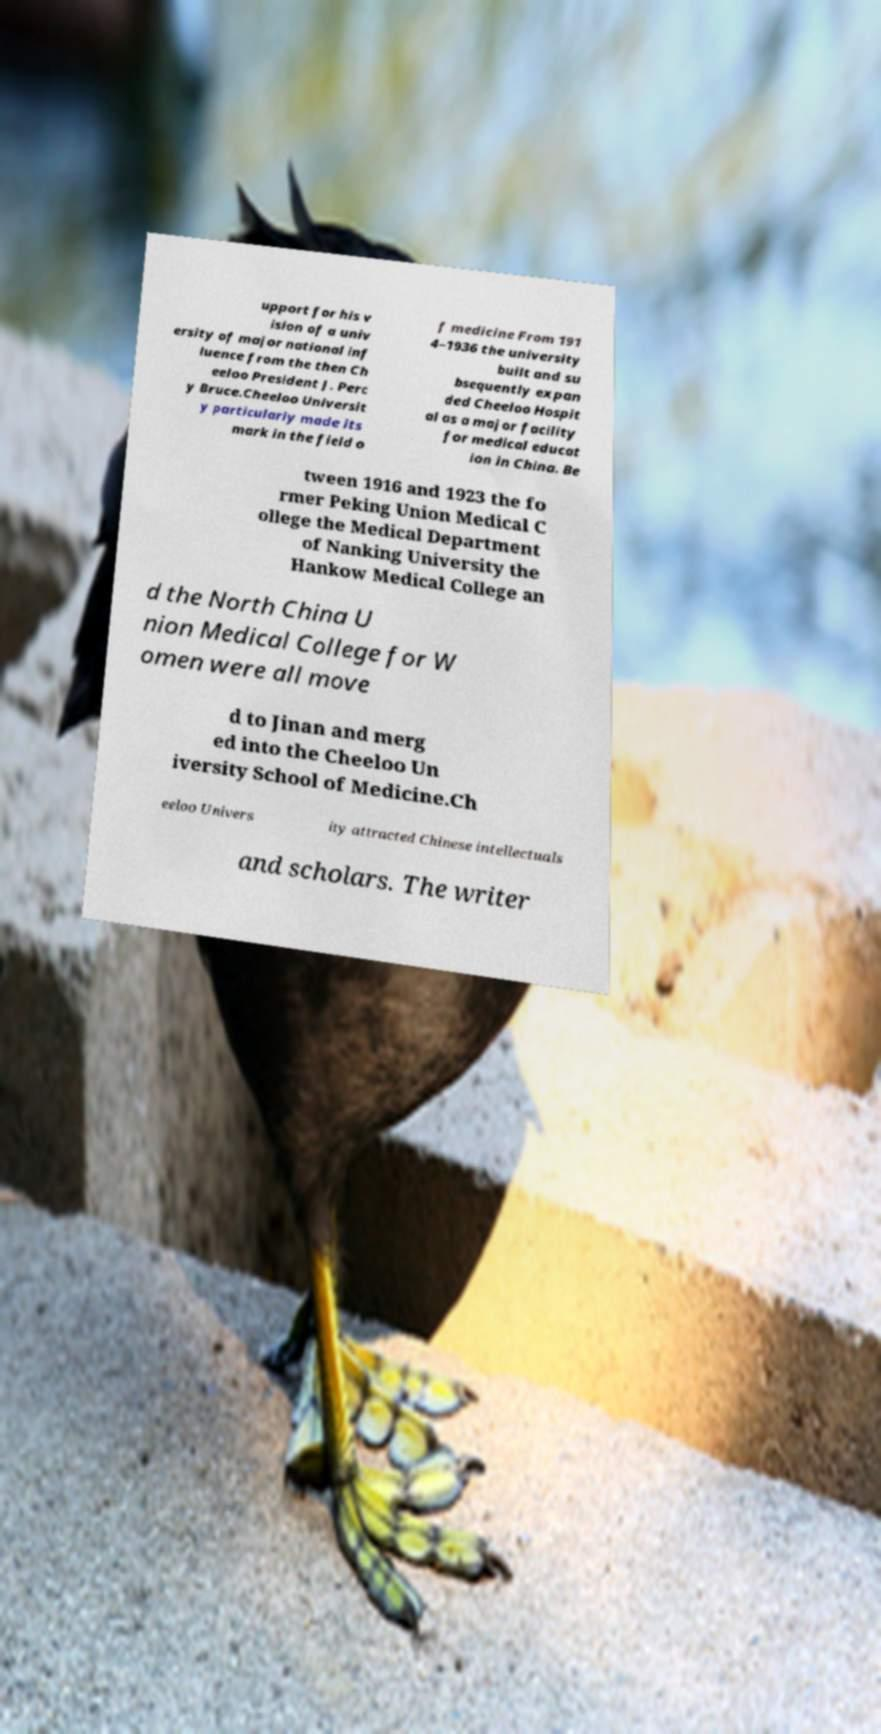Please identify and transcribe the text found in this image. upport for his v ision of a univ ersity of major national inf luence from the then Ch eeloo President J. Perc y Bruce.Cheeloo Universit y particularly made its mark in the field o f medicine From 191 4–1936 the university built and su bsequently expan ded Cheeloo Hospit al as a major facility for medical educat ion in China. Be tween 1916 and 1923 the fo rmer Peking Union Medical C ollege the Medical Department of Nanking University the Hankow Medical College an d the North China U nion Medical College for W omen were all move d to Jinan and merg ed into the Cheeloo Un iversity School of Medicine.Ch eeloo Univers ity attracted Chinese intellectuals and scholars. The writer 